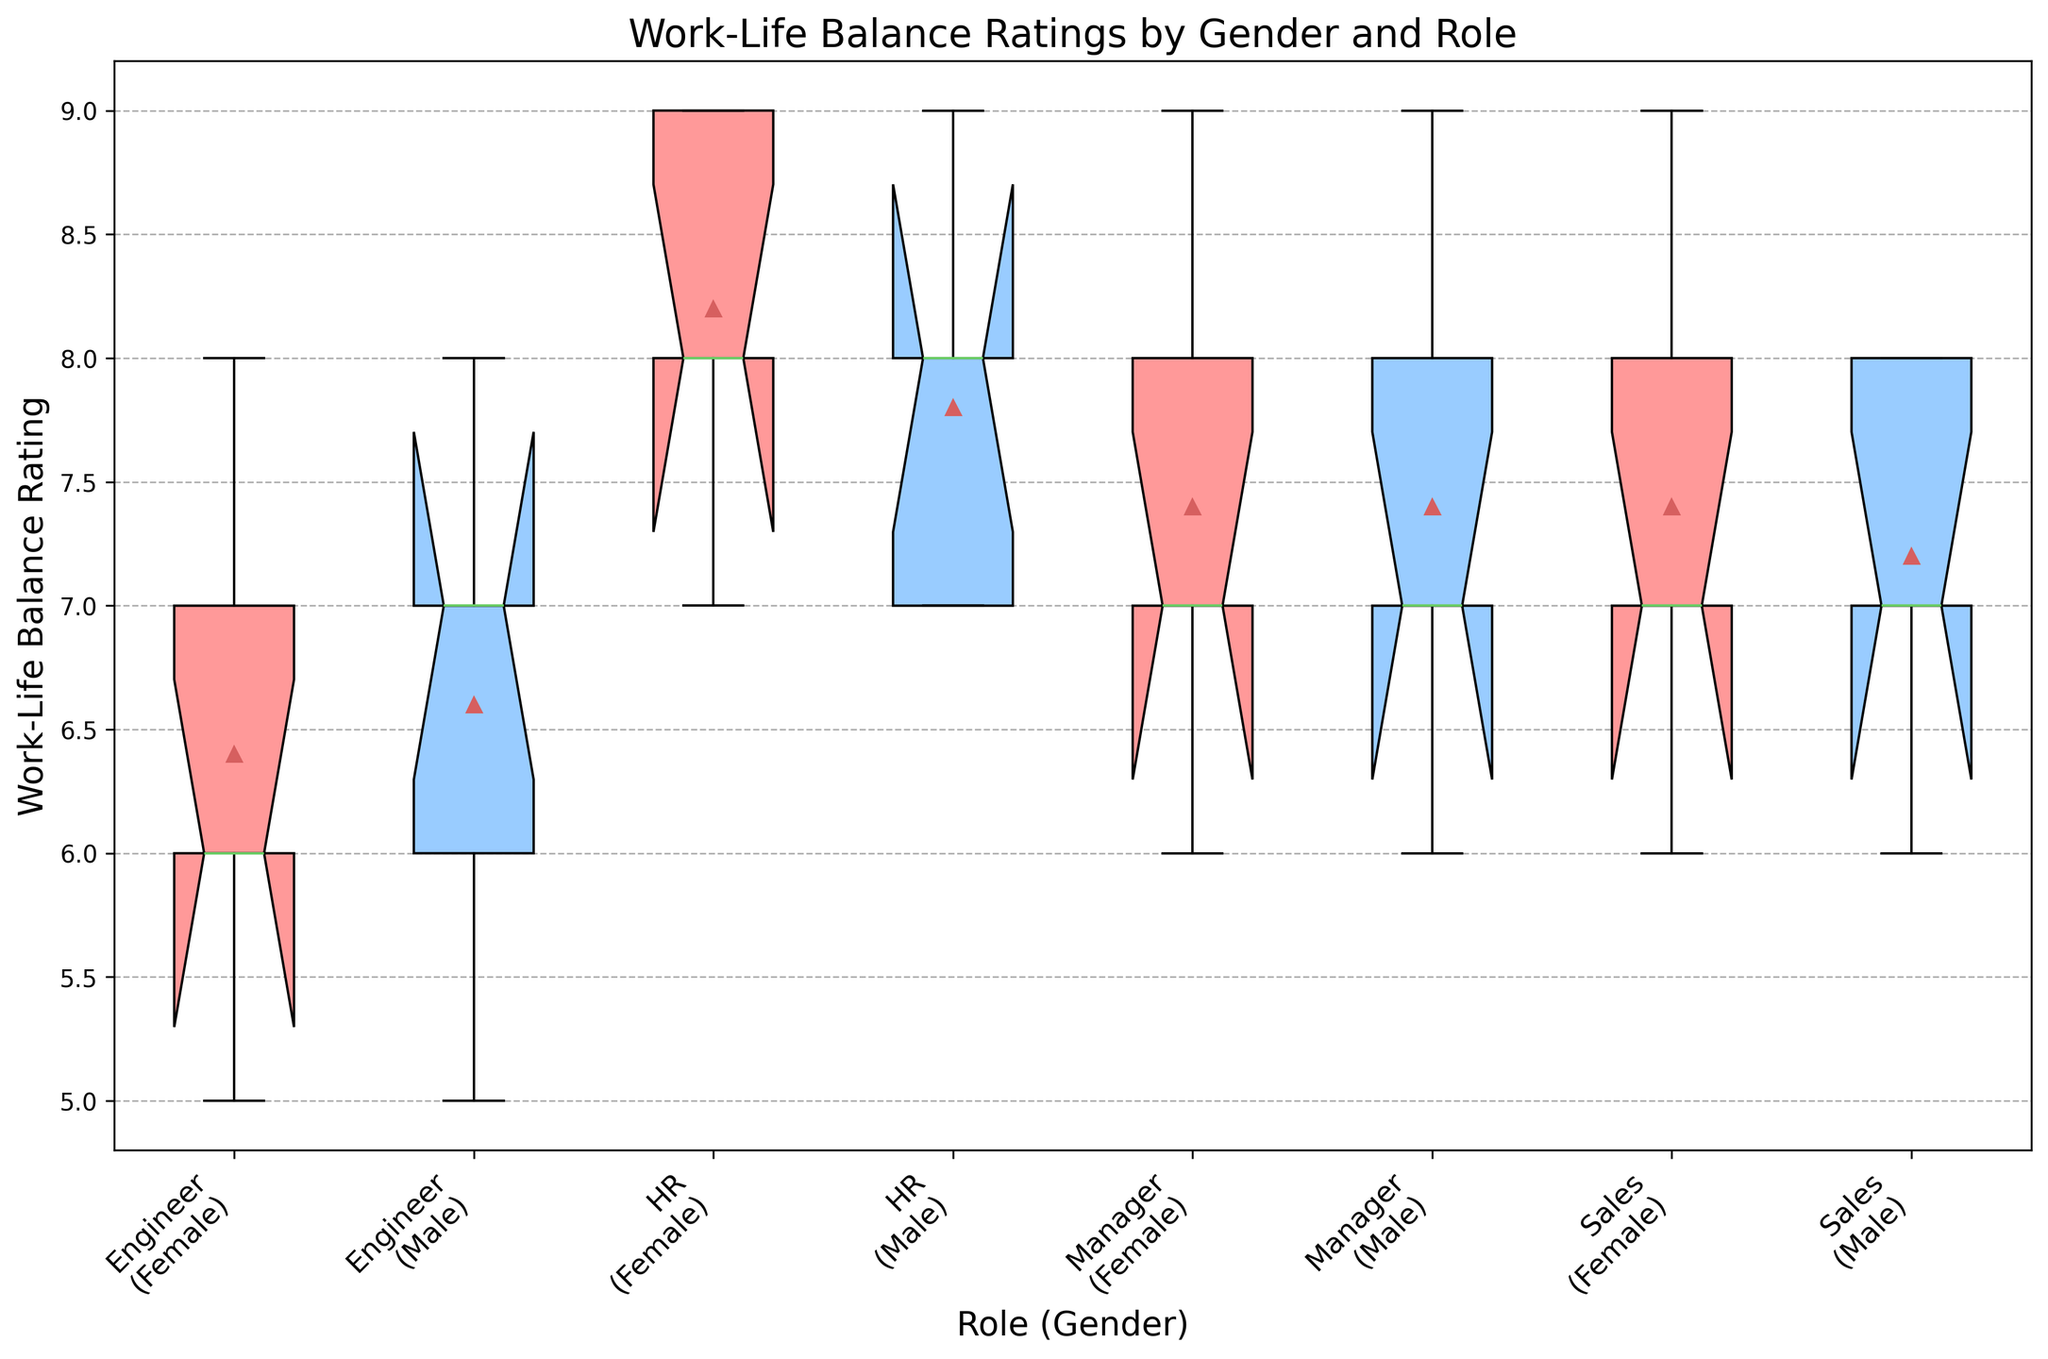What is the median Work-Life Balance Rating for female HR employees? Observe the box plot for the female HR group. The horizontal line inside the box represents the median rating.
Answer: 8 Which role has the highest median Work-Life Balance Rating among males? Compare the horizontal lines inside the boxes for all male roles. The role with the highest median will have the highest line.
Answer: HR Is the median Work-Life Balance Rating higher for female Engineers or female Managers? Compare the medians (horizontal lines inside the boxes) for female Engineers and female Managers.
Answer: Managers Which group shows the widest range of Work-Life Balance Ratings? The range is the distance between the top and bottom whiskers (excluding outliers). Identify the group with the largest distance between its whiskers.
Answer: Sales (Female) Among the male employees, whose Work-Life Balance Rating data shows the smallest interquartile range (IQR)? The IQR is the height of the box, representing the middle 50% of data. Compare the box heights for all male groups to find the smallest.
Answer: HR How does the variability of Work-Life Balance Ratings for female Sales employees compare to male Sales employees? Compare the heights of the boxes and lengths of the whiskers between female and male Sales employees. A taller box and longer whiskers indicate higher variability.
Answer: Female Sales have higher variability What is the difference between the median Work-Life Balance Ratings of male Engineers and male Managers? Subtract the median value of male Engineers from that of male Managers. Compare the horizontal lines within the boxes for these groups.
Answer: 1 Which gender has a higher mean Work-Life Balance Rating for the Engineer role? The mean is marked with a diamond or another special marker within each box plot. Compare means for male and female Engineers.
Answer: Male Are there any groups with outliers in the Work-Life Balance Ratings? Look for dots or markers outside the whiskers of any group’s box plot.
Answer: No outliers What is the median Work-Life Balance Rating for all female employees across all roles? Calculate the average of median ratings of all female groups.
Answer: (7+6+7+8)/4 = 7.25 